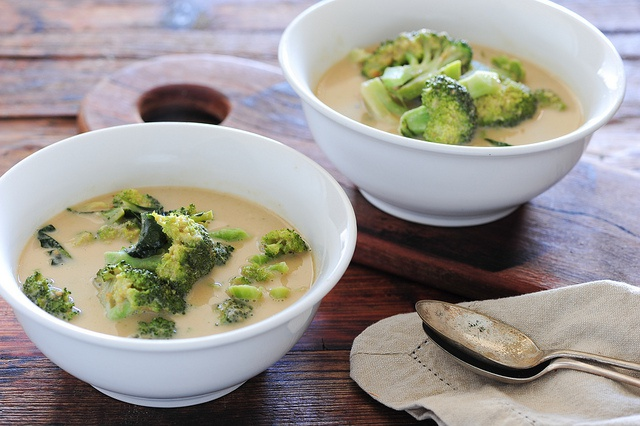Describe the objects in this image and their specific colors. I can see dining table in darkgray, lightgray, black, and tan tones, bowl in darkgray, lightgray, and tan tones, bowl in darkgray, lightgray, and olive tones, broccoli in darkgray, olive, darkgreen, and gray tones, and spoon in darkgray, tan, and gray tones in this image. 